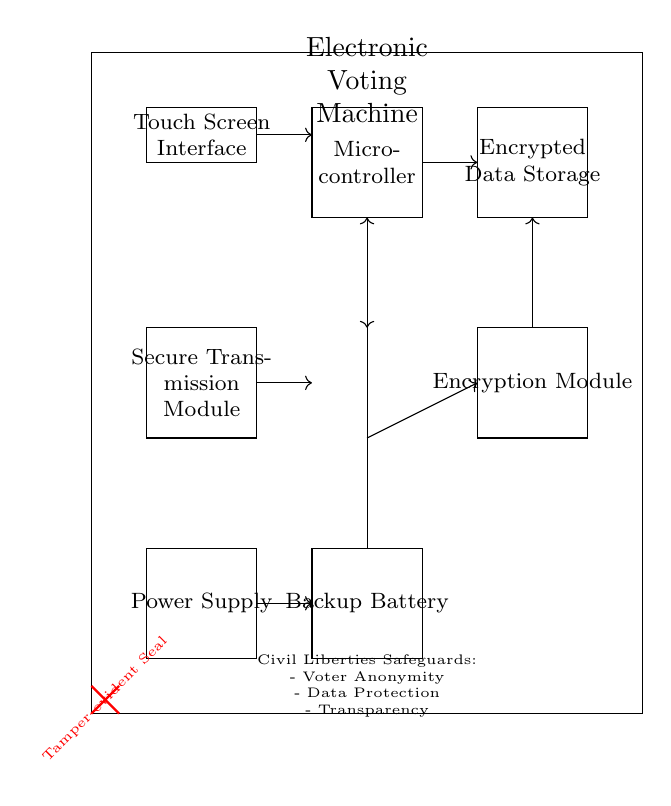What component is responsible for data protection? The component labeled "Encrypted Data Storage" is responsible for data protection, as it is specifically designed to securely store data such that unauthorized access is prevented.
Answer: Encrypted Data Storage What connects the Microcontroller to the Encryption Module? The connection is depicted with an arrow indicating a direct link from the Microcontroller to the Encryption Module, signifying that the Microcontroller sends data that needs to be encrypted to this module.
Answer: Arrow (direct connection) How many main units are shown in this circuit? The circuit diagram illustrates one main unit labeled "Electronic Voting Machine," which encompasses all other components like the Microcontroller and Input Interface.
Answer: One What safeguards are included in the Civil Liberties section? The Civil Liberties section details three specific safeguards: Voter Anonymity, Data Protection, and Transparency that are aimed at ensuring the rights of voters and the integrity of the process.
Answer: Voter Anonymity, Data Protection, Transparency What is the function of the Backup Battery? The Backup Battery ensures that the Electronic Voting Machine remains operational during a power failure, providing an alternative power source to maintain functionality.
Answer: Alternative power source How is tampering detected in this machine? A Tamper-evident Seal is prominently displayed in red, indicating that any unauthorized access attempts will be visibly marked, making it clear that tampering has occurred.
Answer: Tamper-evident Seal 